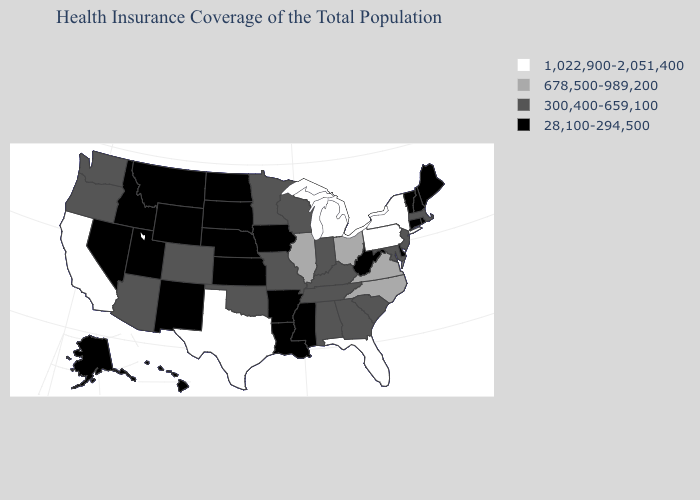Which states hav the highest value in the MidWest?
Keep it brief. Michigan. Does Idaho have the same value as Maine?
Quick response, please. Yes. Name the states that have a value in the range 300,400-659,100?
Short answer required. Alabama, Arizona, Colorado, Georgia, Indiana, Kentucky, Maryland, Massachusetts, Minnesota, Missouri, New Jersey, Oklahoma, Oregon, South Carolina, Tennessee, Washington, Wisconsin. Among the states that border Ohio , which have the lowest value?
Give a very brief answer. West Virginia. What is the value of Delaware?
Short answer required. 28,100-294,500. Is the legend a continuous bar?
Short answer required. No. What is the lowest value in the South?
Give a very brief answer. 28,100-294,500. How many symbols are there in the legend?
Give a very brief answer. 4. Does Mississippi have a higher value than Missouri?
Answer briefly. No. Name the states that have a value in the range 678,500-989,200?
Answer briefly. Illinois, North Carolina, Ohio, Virginia. What is the highest value in the West ?
Give a very brief answer. 1,022,900-2,051,400. What is the lowest value in the South?
Concise answer only. 28,100-294,500. Name the states that have a value in the range 300,400-659,100?
Be succinct. Alabama, Arizona, Colorado, Georgia, Indiana, Kentucky, Maryland, Massachusetts, Minnesota, Missouri, New Jersey, Oklahoma, Oregon, South Carolina, Tennessee, Washington, Wisconsin. Name the states that have a value in the range 300,400-659,100?
Concise answer only. Alabama, Arizona, Colorado, Georgia, Indiana, Kentucky, Maryland, Massachusetts, Minnesota, Missouri, New Jersey, Oklahoma, Oregon, South Carolina, Tennessee, Washington, Wisconsin. Does Michigan have the highest value in the USA?
Be succinct. Yes. 